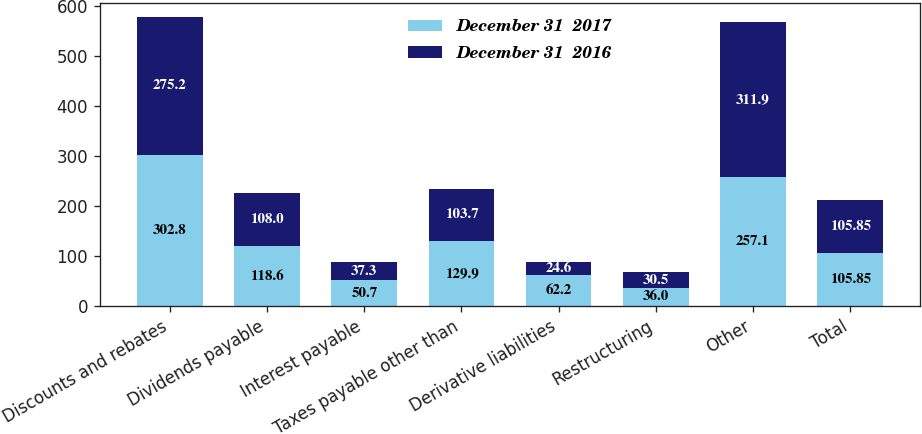Convert chart. <chart><loc_0><loc_0><loc_500><loc_500><stacked_bar_chart><ecel><fcel>Discounts and rebates<fcel>Dividends payable<fcel>Interest payable<fcel>Taxes payable other than<fcel>Derivative liabilities<fcel>Restructuring<fcel>Other<fcel>Total<nl><fcel>December 31  2017<fcel>302.8<fcel>118.6<fcel>50.7<fcel>129.9<fcel>62.2<fcel>36<fcel>257.1<fcel>105.85<nl><fcel>December 31  2016<fcel>275.2<fcel>108<fcel>37.3<fcel>103.7<fcel>24.6<fcel>30.5<fcel>311.9<fcel>105.85<nl></chart> 